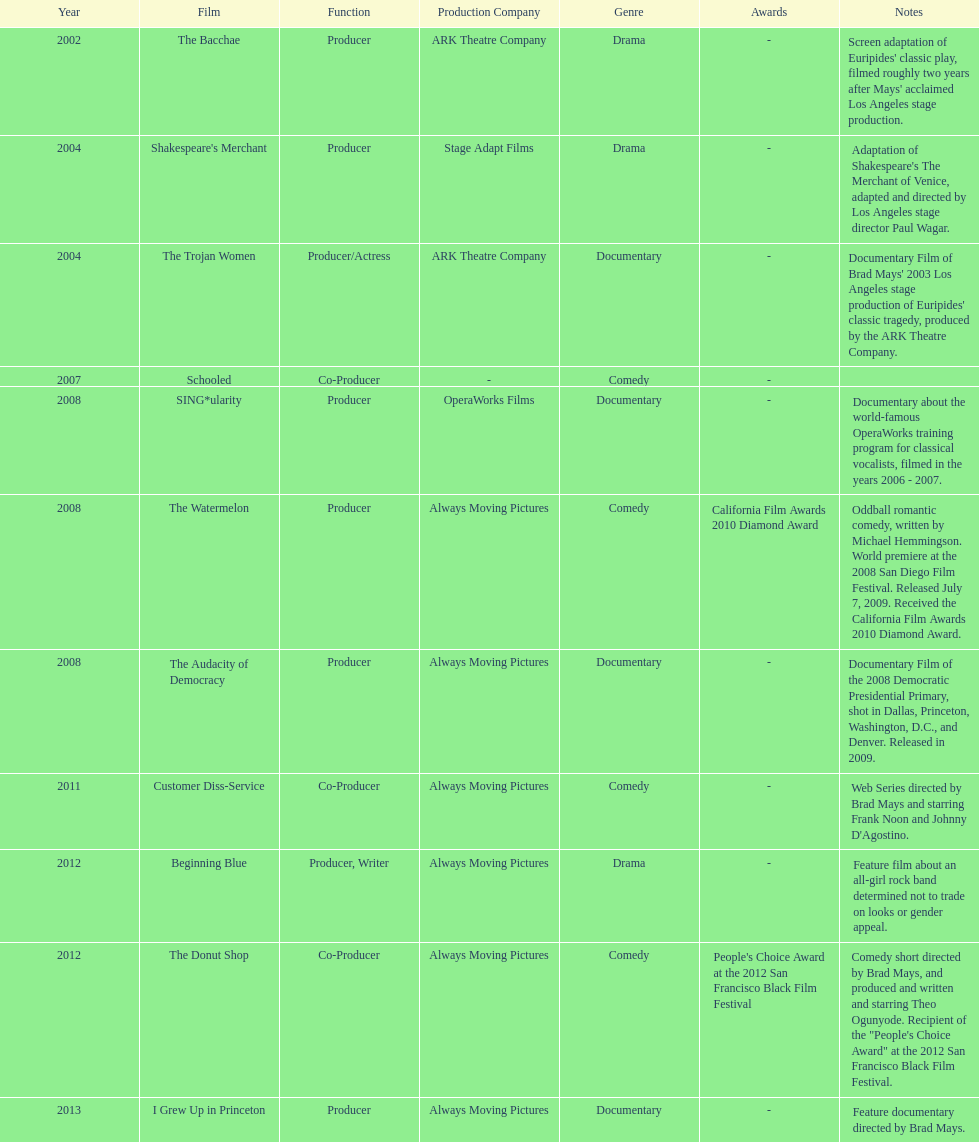In which year did ms. starfelt produce the most films? 2008. 